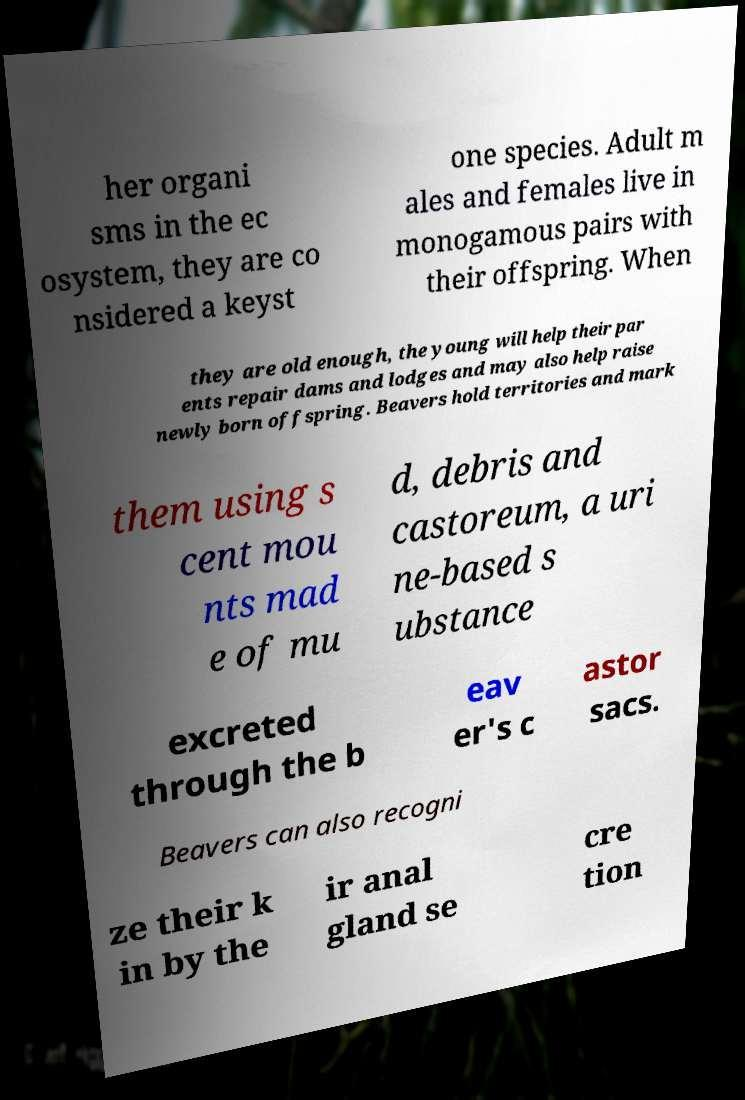Could you assist in decoding the text presented in this image and type it out clearly? her organi sms in the ec osystem, they are co nsidered a keyst one species. Adult m ales and females live in monogamous pairs with their offspring. When they are old enough, the young will help their par ents repair dams and lodges and may also help raise newly born offspring. Beavers hold territories and mark them using s cent mou nts mad e of mu d, debris and castoreum, a uri ne-based s ubstance excreted through the b eav er's c astor sacs. Beavers can also recogni ze their k in by the ir anal gland se cre tion 